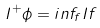Convert formula to latex. <formula><loc_0><loc_0><loc_500><loc_500>I ^ { + } \phi = i n f _ { f } I f</formula> 